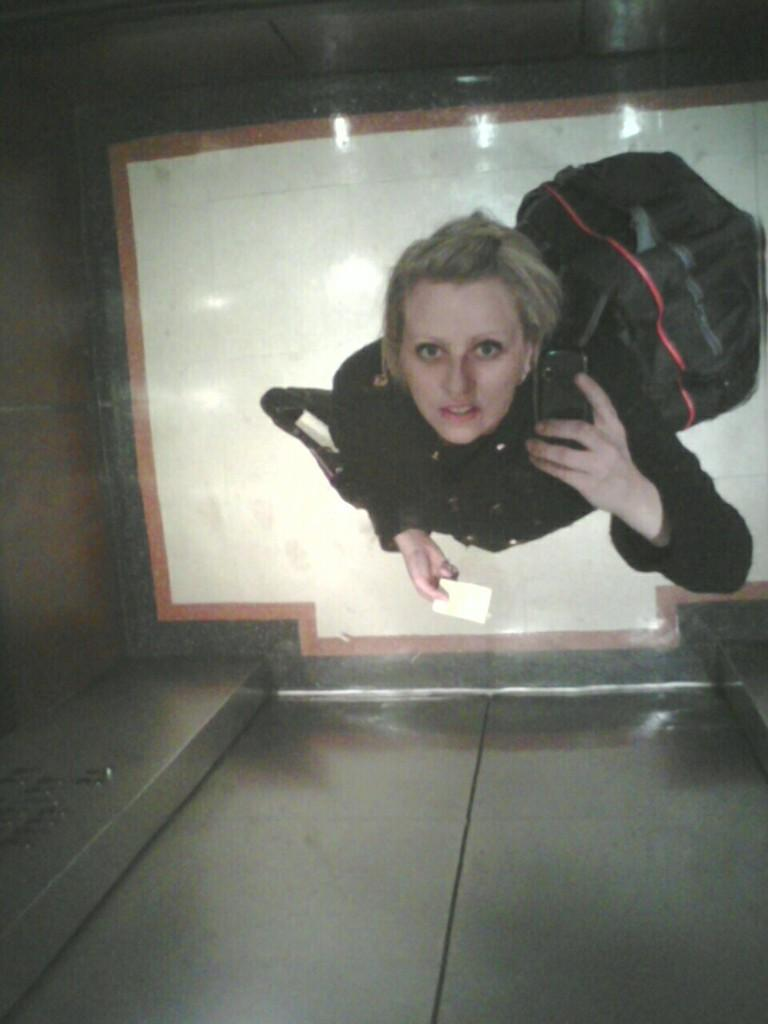What is the person in the image holding? The person is holding a mobile in the image. What else can be seen on the person in the image? The person is wearing a bag. What can be seen in the background of the image? There is a floor visible in the background of the image. What type of pin can be seen holding the person's clothes together in the image? There is no pin visible in the image; the person's clothes are not being held together by a pin. 